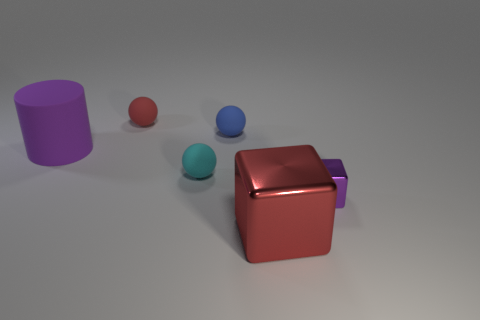Add 1 rubber cylinders. How many objects exist? 7 Subtract all small cyan matte spheres. How many spheres are left? 2 Subtract 2 balls. How many balls are left? 1 Subtract 0 green cylinders. How many objects are left? 6 Subtract all cylinders. How many objects are left? 5 Subtract all brown cubes. Subtract all cyan balls. How many cubes are left? 2 Subtract all cyan cylinders. How many red spheres are left? 1 Subtract all big purple matte cylinders. Subtract all small rubber balls. How many objects are left? 2 Add 2 matte things. How many matte things are left? 6 Add 4 matte cylinders. How many matte cylinders exist? 5 